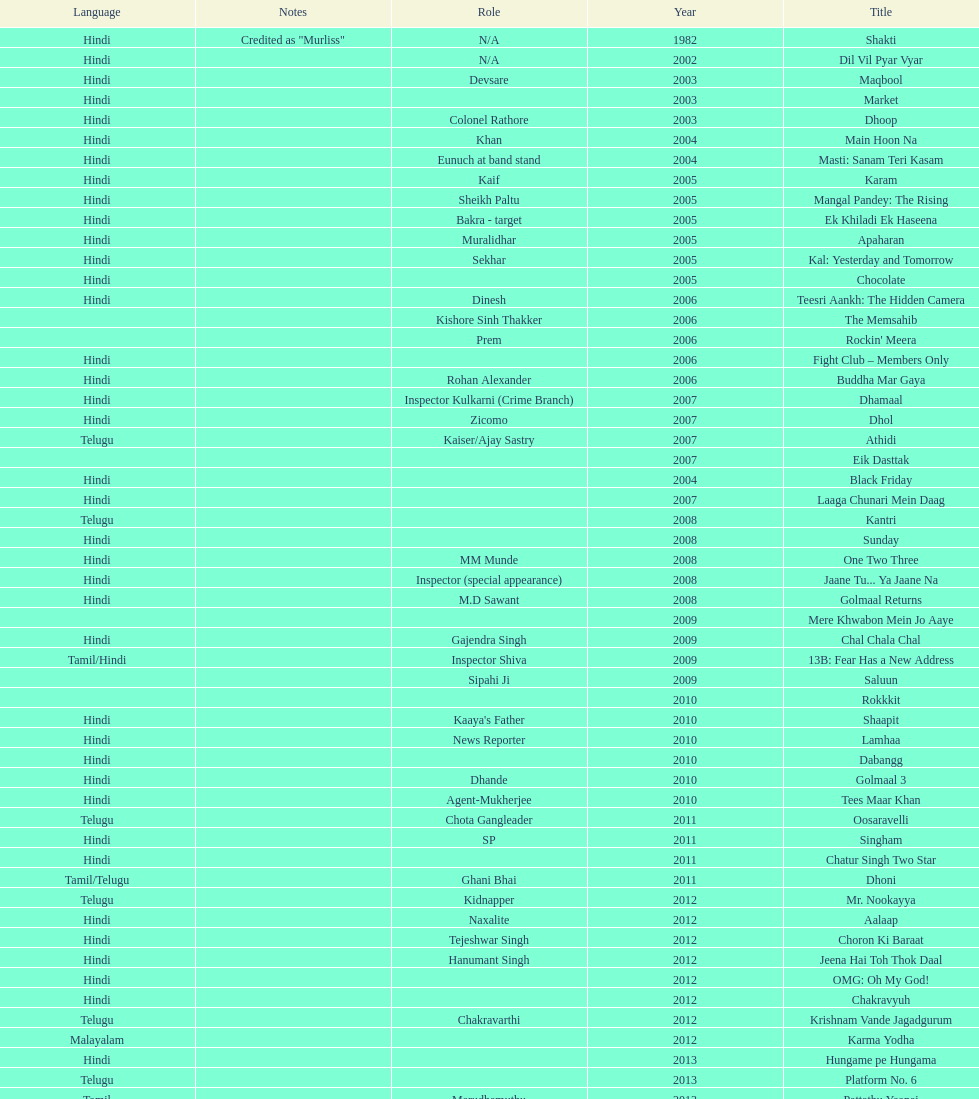What title is before dhol in 2007? Dhamaal. 